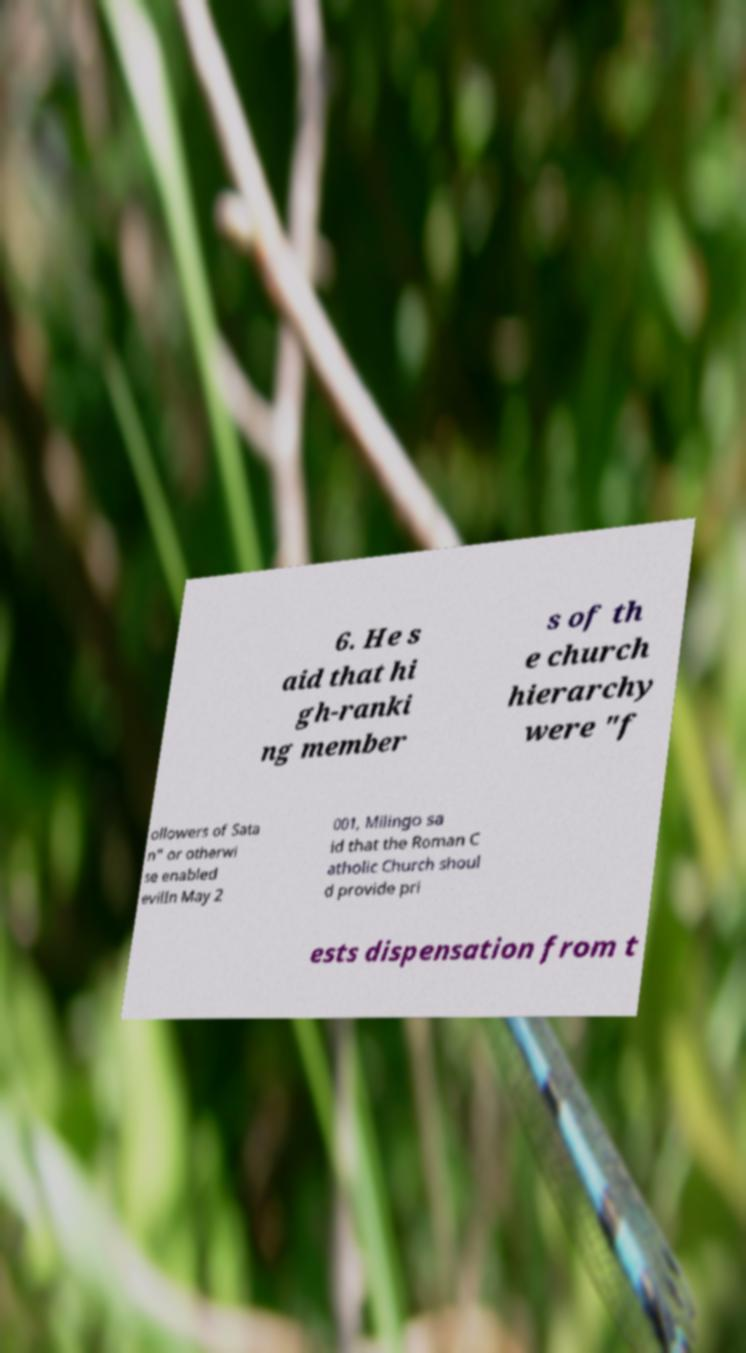What messages or text are displayed in this image? I need them in a readable, typed format. 6. He s aid that hi gh-ranki ng member s of th e church hierarchy were "f ollowers of Sata n" or otherwi se enabled evilIn May 2 001, Milingo sa id that the Roman C atholic Church shoul d provide pri ests dispensation from t 